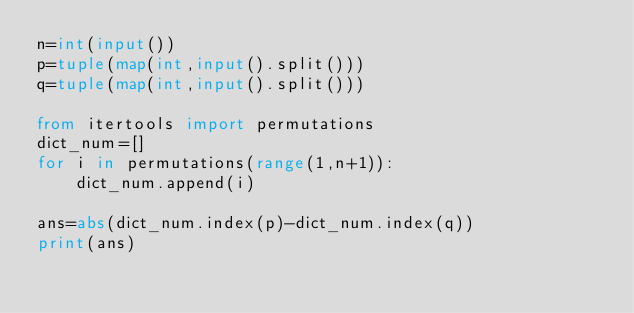Convert code to text. <code><loc_0><loc_0><loc_500><loc_500><_Python_>n=int(input())
p=tuple(map(int,input().split()))
q=tuple(map(int,input().split()))

from itertools import permutations
dict_num=[]
for i in permutations(range(1,n+1)):
    dict_num.append(i)

ans=abs(dict_num.index(p)-dict_num.index(q))
print(ans)</code> 